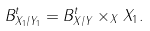<formula> <loc_0><loc_0><loc_500><loc_500>B ^ { t } _ { X _ { 1 } / Y _ { 1 } } = B _ { X / Y } ^ { t } \times _ { X } X _ { 1 } .</formula> 